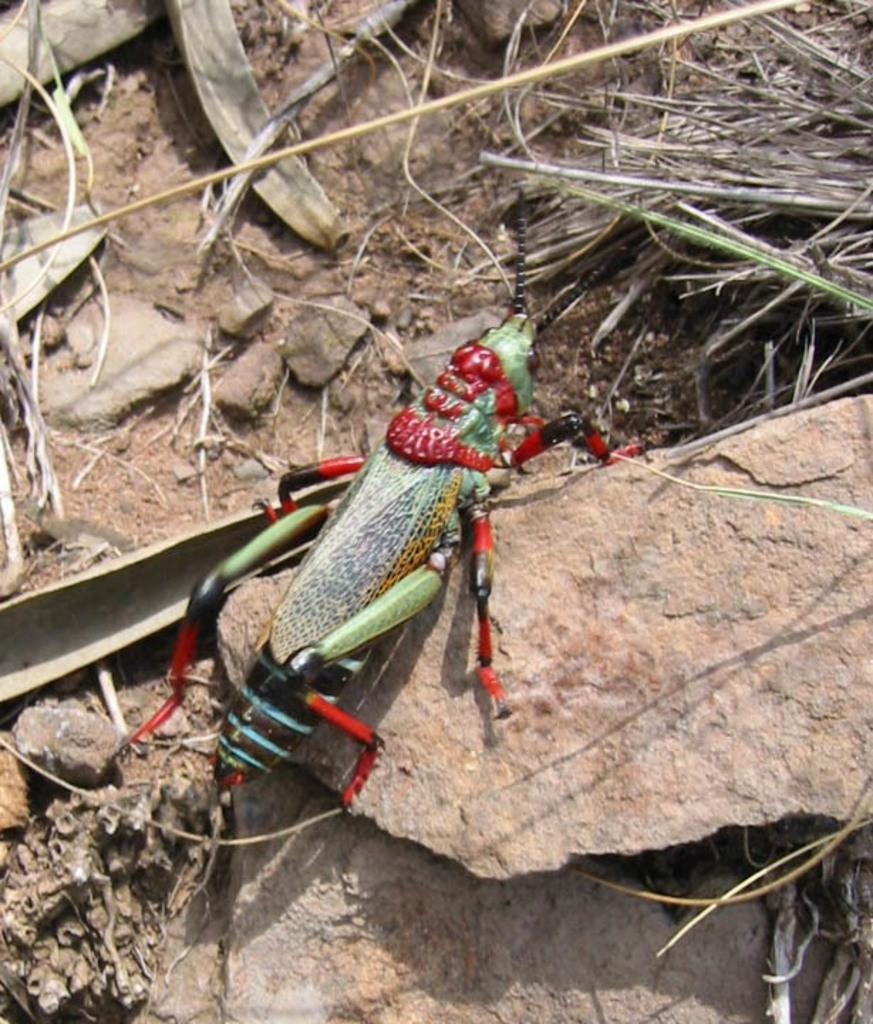What is on the stone in the image? There is an insect on the stone in the image. Where is the stone located? The stone is on the ground in the image. What type of vegetation can be seen in the image? Grass is present in the image. What else can be seen on the ground in the image? There are small stones visible in the image. What type of office is visible in the image? There is no office present in the image; it features an insect on a stone with grass and small stones in the background. 